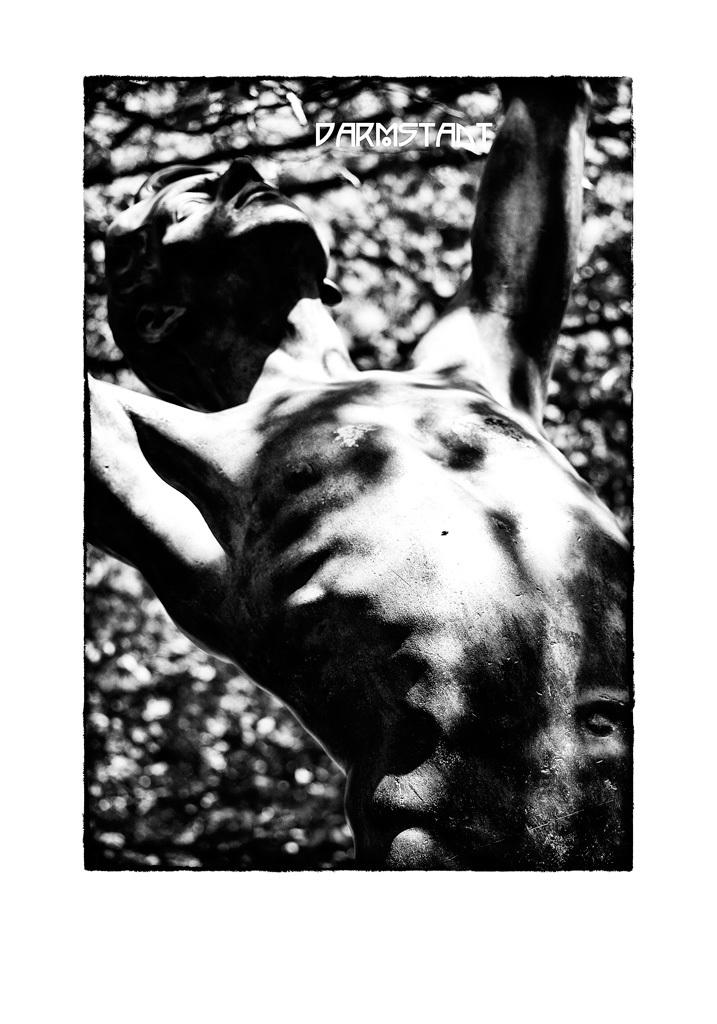What is the color scheme of the image? The image is black and white. What can be seen in the image besides the color scheme? There is a statue of a person in the image. Is there any additional information or marking on the image? Yes, there is a watermark on the image. How many passengers are visible in the image? There are no passengers present in the image; it features a statue of a person. Are there any women depicted in the image? The image only features a statue of a person, and it is not specified whether the statue is of a man or a woman. 